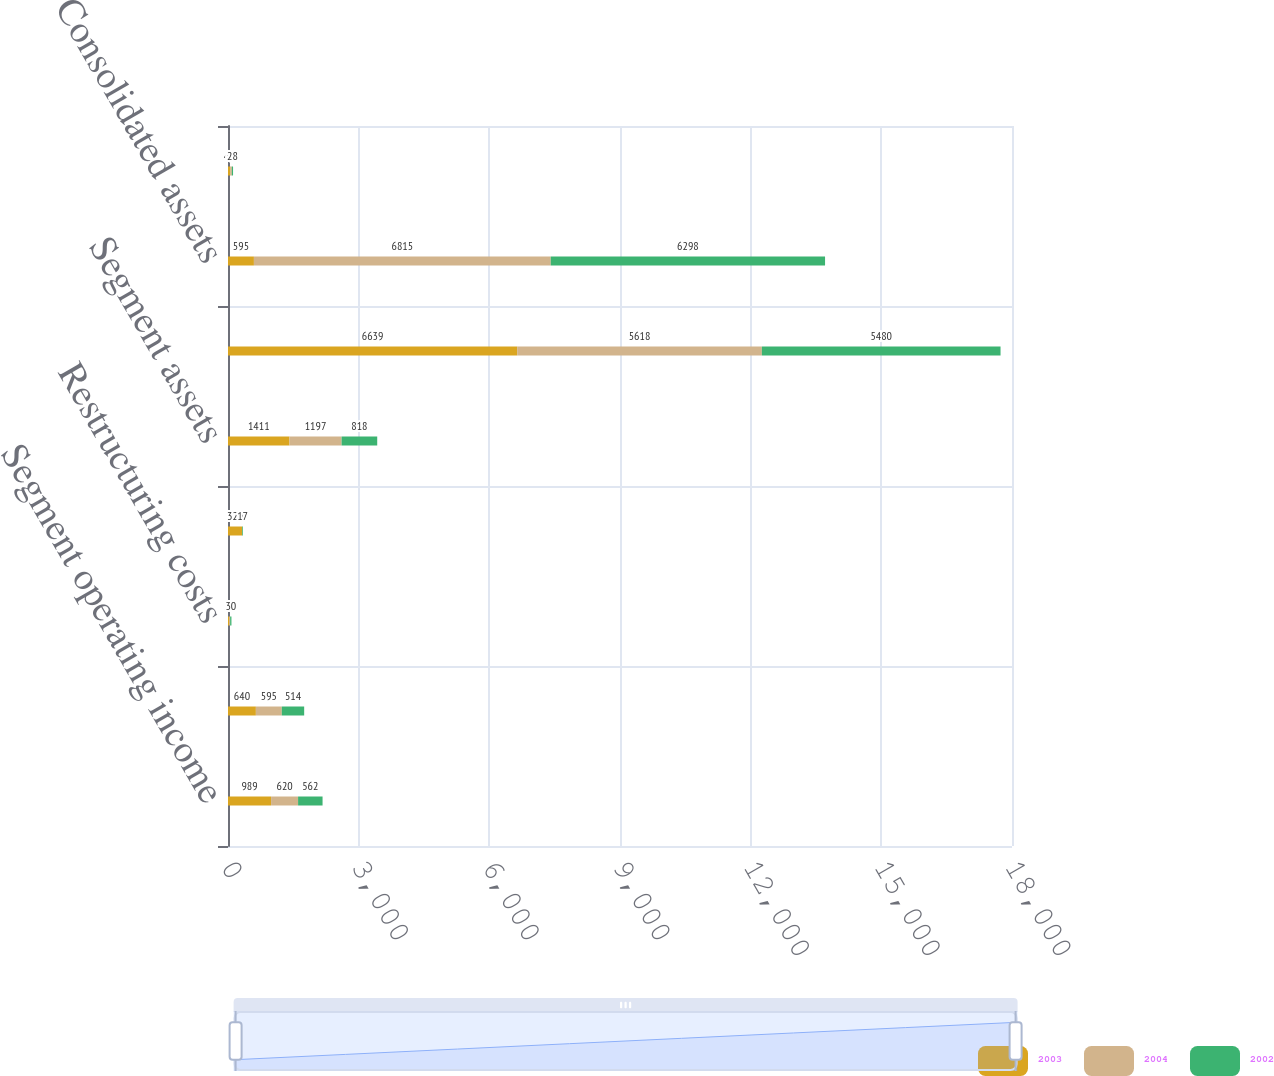Convert chart to OTSL. <chart><loc_0><loc_0><loc_500><loc_500><stacked_bar_chart><ecel><fcel>Segment operating income<fcel>Corporate expenses net<fcel>Restructuring costs<fcel>Consolidated operating income<fcel>Segment assets<fcel>Corporate assets<fcel>Consolidated assets<fcel>Segment depreciation<nl><fcel>2003<fcel>989<fcel>640<fcel>23<fcel>326<fcel>1411<fcel>6639<fcel>595<fcel>49<nl><fcel>2004<fcel>620<fcel>595<fcel>26<fcel>1<fcel>1197<fcel>5618<fcel>6815<fcel>39<nl><fcel>2002<fcel>562<fcel>514<fcel>30<fcel>17<fcel>818<fcel>5480<fcel>6298<fcel>28<nl></chart> 